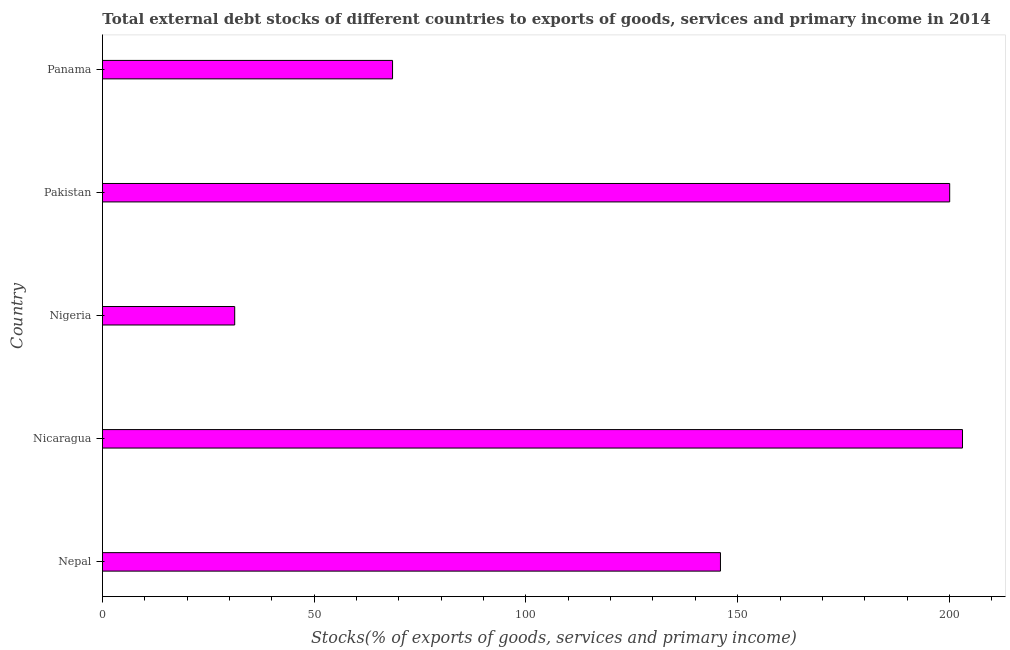Does the graph contain any zero values?
Give a very brief answer. No. What is the title of the graph?
Offer a very short reply. Total external debt stocks of different countries to exports of goods, services and primary income in 2014. What is the label or title of the X-axis?
Your response must be concise. Stocks(% of exports of goods, services and primary income). What is the label or title of the Y-axis?
Offer a terse response. Country. What is the external debt stocks in Nepal?
Your response must be concise. 145.94. Across all countries, what is the maximum external debt stocks?
Your answer should be very brief. 203.09. Across all countries, what is the minimum external debt stocks?
Your response must be concise. 31.23. In which country was the external debt stocks maximum?
Give a very brief answer. Nicaragua. In which country was the external debt stocks minimum?
Offer a very short reply. Nigeria. What is the sum of the external debt stocks?
Give a very brief answer. 648.83. What is the difference between the external debt stocks in Nepal and Panama?
Make the answer very short. 77.44. What is the average external debt stocks per country?
Provide a short and direct response. 129.77. What is the median external debt stocks?
Make the answer very short. 145.94. In how many countries, is the external debt stocks greater than 140 %?
Your answer should be very brief. 3. What is the ratio of the external debt stocks in Nepal to that in Nicaragua?
Give a very brief answer. 0.72. Is the external debt stocks in Nepal less than that in Nigeria?
Your answer should be very brief. No. Is the difference between the external debt stocks in Nepal and Panama greater than the difference between any two countries?
Your answer should be very brief. No. What is the difference between the highest and the second highest external debt stocks?
Your answer should be compact. 3.02. Is the sum of the external debt stocks in Nigeria and Pakistan greater than the maximum external debt stocks across all countries?
Offer a very short reply. Yes. What is the difference between the highest and the lowest external debt stocks?
Your answer should be compact. 171.87. How many bars are there?
Ensure brevity in your answer.  5. Are all the bars in the graph horizontal?
Provide a succinct answer. Yes. What is the difference between two consecutive major ticks on the X-axis?
Your answer should be compact. 50. Are the values on the major ticks of X-axis written in scientific E-notation?
Ensure brevity in your answer.  No. What is the Stocks(% of exports of goods, services and primary income) of Nepal?
Make the answer very short. 145.94. What is the Stocks(% of exports of goods, services and primary income) in Nicaragua?
Your answer should be compact. 203.09. What is the Stocks(% of exports of goods, services and primary income) of Nigeria?
Offer a terse response. 31.23. What is the Stocks(% of exports of goods, services and primary income) in Pakistan?
Your answer should be compact. 200.07. What is the Stocks(% of exports of goods, services and primary income) in Panama?
Offer a very short reply. 68.5. What is the difference between the Stocks(% of exports of goods, services and primary income) in Nepal and Nicaragua?
Your answer should be very brief. -57.16. What is the difference between the Stocks(% of exports of goods, services and primary income) in Nepal and Nigeria?
Provide a succinct answer. 114.71. What is the difference between the Stocks(% of exports of goods, services and primary income) in Nepal and Pakistan?
Provide a succinct answer. -54.14. What is the difference between the Stocks(% of exports of goods, services and primary income) in Nepal and Panama?
Your answer should be very brief. 77.43. What is the difference between the Stocks(% of exports of goods, services and primary income) in Nicaragua and Nigeria?
Ensure brevity in your answer.  171.87. What is the difference between the Stocks(% of exports of goods, services and primary income) in Nicaragua and Pakistan?
Offer a terse response. 3.02. What is the difference between the Stocks(% of exports of goods, services and primary income) in Nicaragua and Panama?
Make the answer very short. 134.59. What is the difference between the Stocks(% of exports of goods, services and primary income) in Nigeria and Pakistan?
Ensure brevity in your answer.  -168.84. What is the difference between the Stocks(% of exports of goods, services and primary income) in Nigeria and Panama?
Your response must be concise. -37.27. What is the difference between the Stocks(% of exports of goods, services and primary income) in Pakistan and Panama?
Ensure brevity in your answer.  131.57. What is the ratio of the Stocks(% of exports of goods, services and primary income) in Nepal to that in Nicaragua?
Keep it short and to the point. 0.72. What is the ratio of the Stocks(% of exports of goods, services and primary income) in Nepal to that in Nigeria?
Your answer should be very brief. 4.67. What is the ratio of the Stocks(% of exports of goods, services and primary income) in Nepal to that in Pakistan?
Offer a very short reply. 0.73. What is the ratio of the Stocks(% of exports of goods, services and primary income) in Nepal to that in Panama?
Give a very brief answer. 2.13. What is the ratio of the Stocks(% of exports of goods, services and primary income) in Nicaragua to that in Nigeria?
Offer a terse response. 6.5. What is the ratio of the Stocks(% of exports of goods, services and primary income) in Nicaragua to that in Panama?
Your answer should be very brief. 2.96. What is the ratio of the Stocks(% of exports of goods, services and primary income) in Nigeria to that in Pakistan?
Provide a short and direct response. 0.16. What is the ratio of the Stocks(% of exports of goods, services and primary income) in Nigeria to that in Panama?
Keep it short and to the point. 0.46. What is the ratio of the Stocks(% of exports of goods, services and primary income) in Pakistan to that in Panama?
Your answer should be compact. 2.92. 